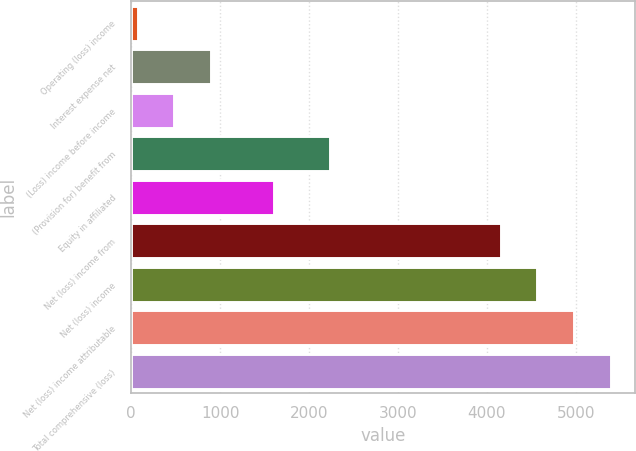Convert chart. <chart><loc_0><loc_0><loc_500><loc_500><bar_chart><fcel>Operating (loss) income<fcel>Interest expense net<fcel>(Loss) income before income<fcel>(Provision for) benefit from<fcel>Equity in affiliated<fcel>Net (loss) income from<fcel>Net (loss) income<fcel>Net (loss) income attributable<fcel>Total comprehensive (loss)<nl><fcel>72<fcel>897.4<fcel>484.7<fcel>2233<fcel>1609<fcel>4154<fcel>4566.7<fcel>4979.4<fcel>5392.1<nl></chart> 